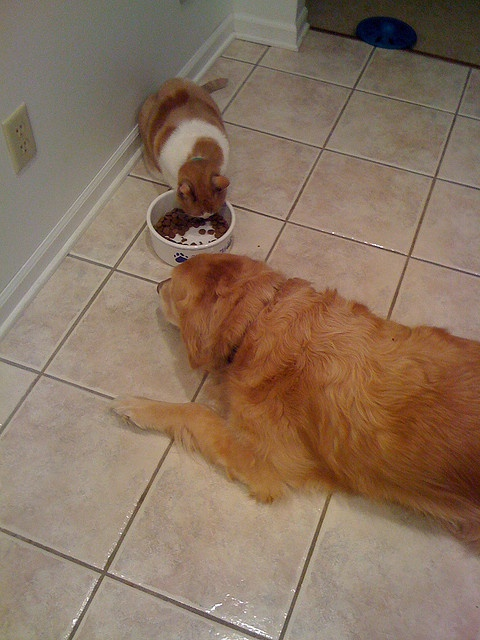Describe the objects in this image and their specific colors. I can see dog in gray, brown, and maroon tones, cat in gray, maroon, darkgray, and brown tones, and bowl in gray, black, and darkgray tones in this image. 